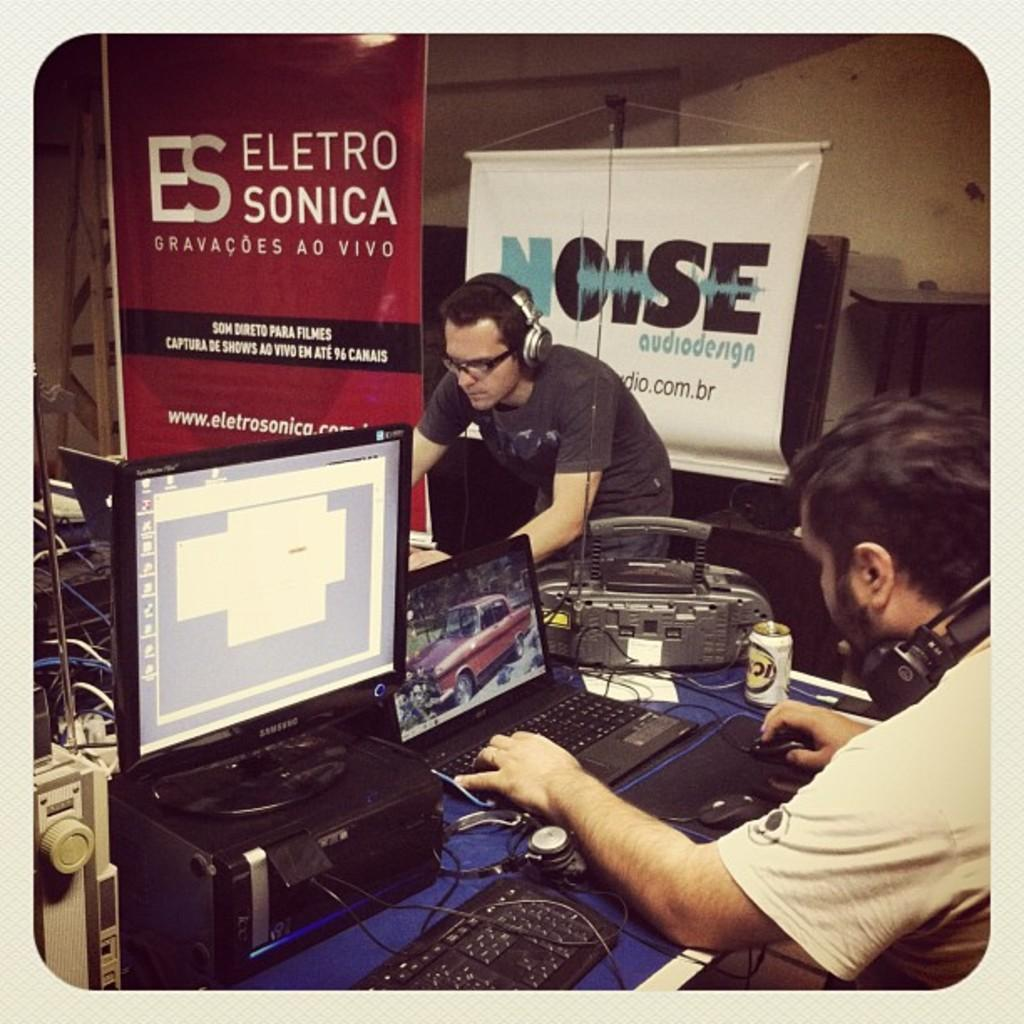<image>
Offer a succinct explanation of the picture presented. Two men working on laptops with a sign about noisde behind the man that is standing. 